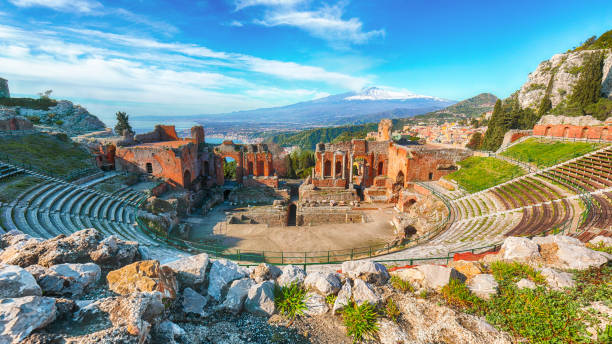Analyze the image in a comprehensive and detailed manner. This image showcases the ancient Greek theater in Taormina, Italy, beautifully perched amidst nature. Carved meticulously into a cliffside, the theater exemplifies the incredible craftsmanship of the ancient Greeks. It is constructed predominantly from stone, comprising rows of semi-circular seating which cascade down to a historically significant stage. Despite the passage of centuries, the theater remains remarkably preserved, standing as a testament to time. Occupying a vantage point over the Mediterranean Sea, the blue expanse of water juxtaposes vividly against the earthy tones of the theater and the verdant surroundings. Remarkably, Mount Etna, with its imposing silhouette and often snow-capped peak, enhances the majestic quality of this vista. The photograph itself is taken from above, offering a panoramic perspective that sweeps across the theater, the shimmering sea, and the iconic volcanic landscape, encapsulating the allure of this historic landmark. 